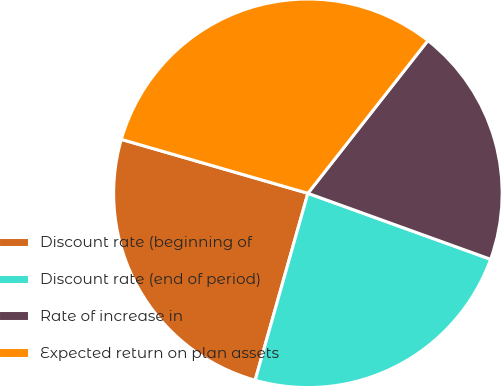<chart> <loc_0><loc_0><loc_500><loc_500><pie_chart><fcel>Discount rate (beginning of<fcel>Discount rate (end of period)<fcel>Rate of increase in<fcel>Expected return on plan assets<nl><fcel>25.1%<fcel>23.86%<fcel>19.92%<fcel>31.12%<nl></chart> 